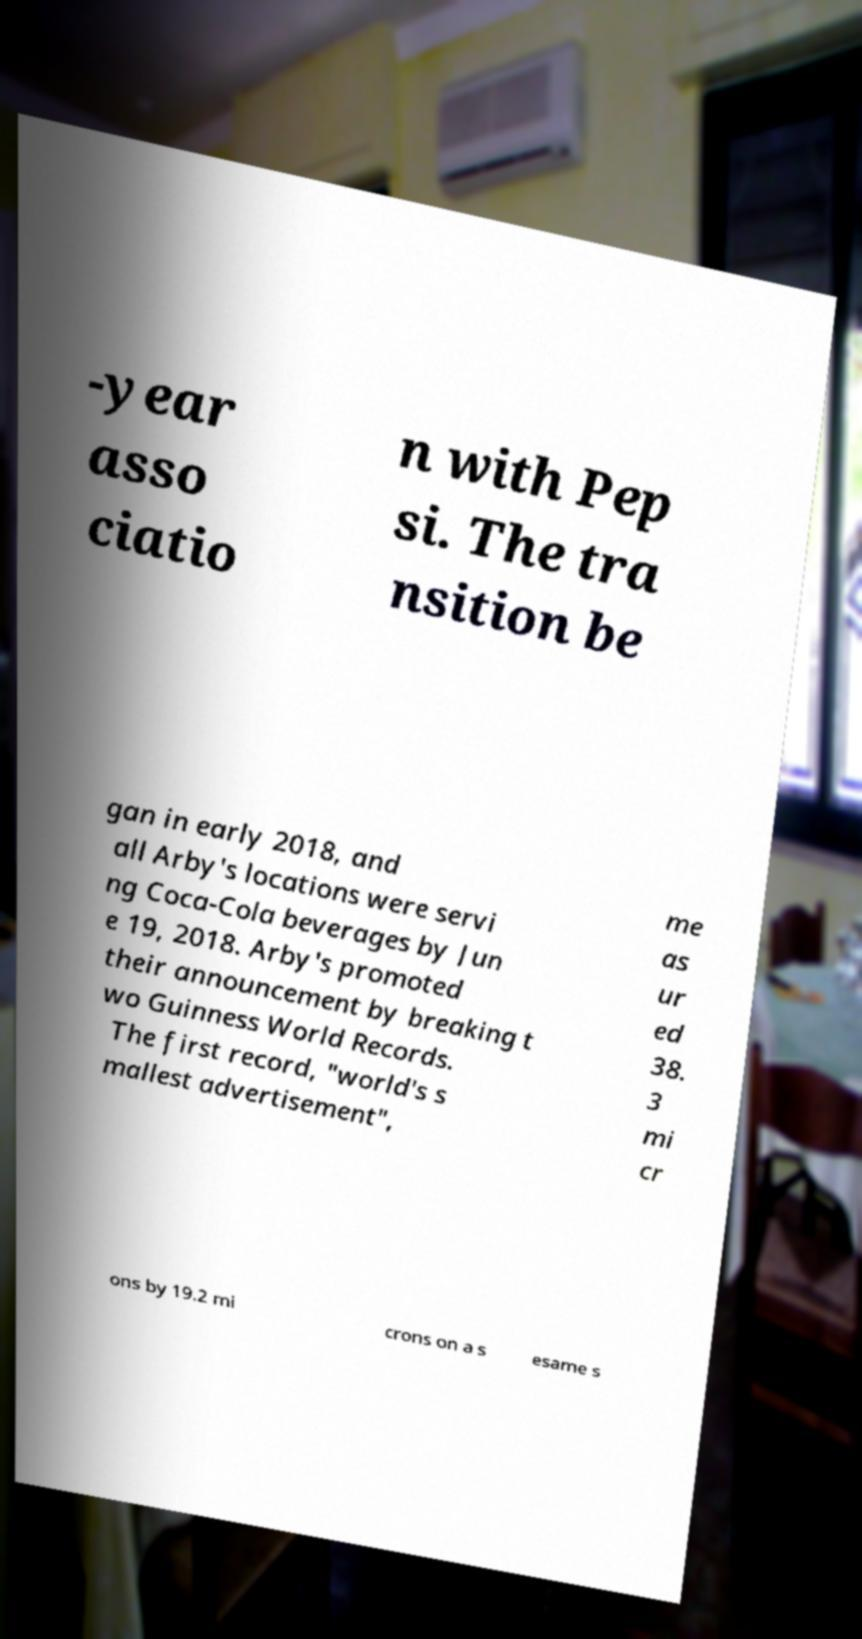For documentation purposes, I need the text within this image transcribed. Could you provide that? -year asso ciatio n with Pep si. The tra nsition be gan in early 2018, and all Arby's locations were servi ng Coca-Cola beverages by Jun e 19, 2018. Arby's promoted their announcement by breaking t wo Guinness World Records. The first record, "world's s mallest advertisement", me as ur ed 38. 3 mi cr ons by 19.2 mi crons on a s esame s 